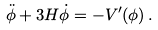<formula> <loc_0><loc_0><loc_500><loc_500>\ddot { \phi } + 3 H \dot { \phi } = - V ^ { \prime } ( \phi ) \, .</formula> 